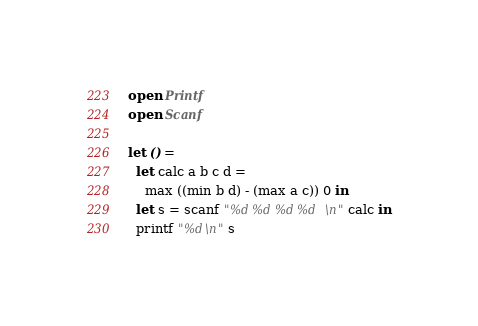<code> <loc_0><loc_0><loc_500><loc_500><_OCaml_>open Printf
open Scanf

let () =
  let calc a b c d =
    max ((min b d) - (max a c)) 0 in
  let s = scanf "%d %d %d %d\n" calc in
  printf "%d\n" s
</code> 